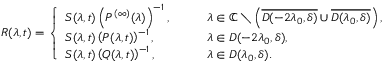<formula> <loc_0><loc_0><loc_500><loc_500>R ( \lambda , t ) = \left \{ \begin{array} { l l } { S ( \lambda , t ) \left ( P ^ { ( \infty ) } ( \lambda ) \right ) ^ { - 1 } , } & { \quad \lambda \in \mathbb { C } \ \left ( \overline { { D ( - 2 \lambda _ { 0 } , \delta ) } } \cup \overline { { D ( \lambda _ { 0 } , \delta ) } } \right ) , } \\ { S ( \lambda , t ) \left ( P ( \lambda , t ) \right ) ^ { - 1 } , } & { \quad \lambda \in D ( - 2 \lambda _ { 0 } , \delta ) , } \\ { S ( \lambda , t ) \left ( Q ( \lambda , t ) \right ) ^ { - 1 } , } & { \quad \lambda \in D ( \lambda _ { 0 } , \delta ) . } \end{array}</formula> 